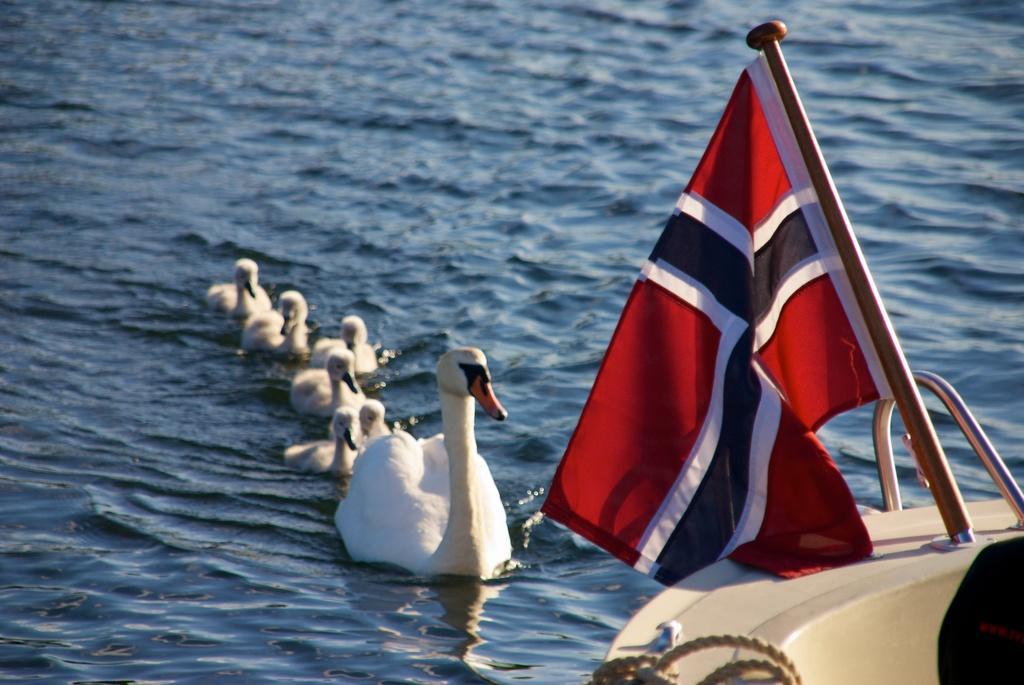In one or two sentences, can you explain what this image depicts? In this picture, we see the swans are swimming in the water. In the right bottom, we see a ship and a flag in red, white and black color. In the background, we see water and this water might be in the lake. 